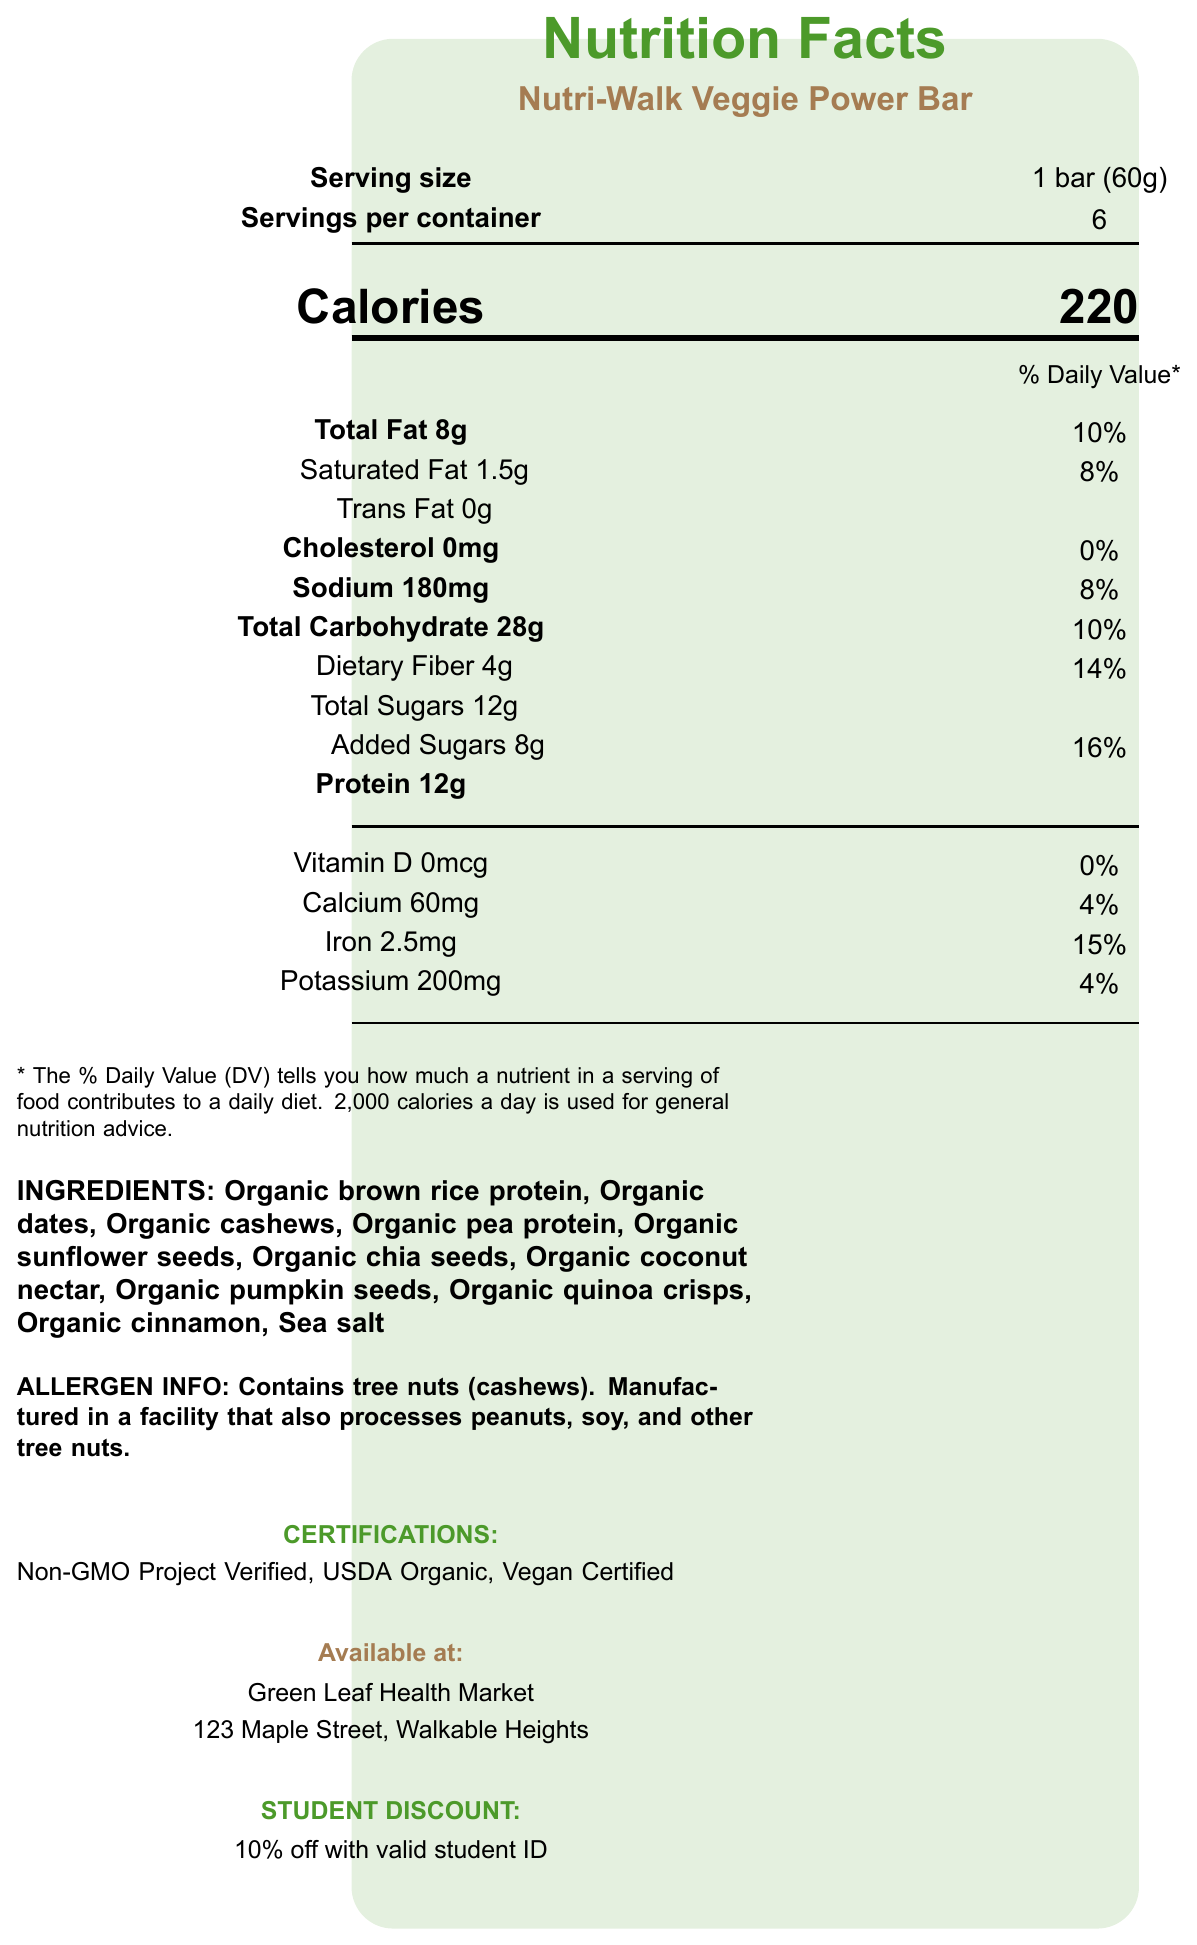what is the serving size? The serving size is listed in the "Serving information" section as "1 bar (60g)".
Answer: 1 bar (60g) how many calories are in one serving? The calories are clearly indicated in the "Calories" section of the document.
Answer: 220 what is the total fat content per serving? The "Total Fat" content is listed under the "Nutrients" section as 8g.
Answer: 8g how much fiber is in each serving? The "Dietary Fiber" content is specified in the "Nutrients" section as 4g.
Answer: 4g are there any added sugars in the protein bar? The document lists "Added Sugars" in the "Nutrients" section with an amount of 8g.
Answer: Yes what certifications does the Nutri-Walk Veggie Power Bar have? The certifications are listed in the "Certifications" section.
Answer: Non-GMO Project Verified, USDA Organic, Vegan Certified what is the amount of sodium per serving? The sodium content is listed under the "Nutrients" section as 180mg.
Answer: 180mg how many bars are in one container? The "Servings per container" is listed in the "Serving information" section as 6.
Answer: 6 which ingredient might cause allergies? The "Allergen Info" states that the bar contains tree nuts (cashews).
Answer: Cashews where can you buy this protein bar? The "Available at" section specifies that the bar can be purchased at Green Leaf Health Market.
Answer: Green Leaf Health Market how much iron does one serving have? The iron content is specified under "Nutrients" as 2.5mg.
Answer: 2.5mg what promotion is available for students? The "Student Discount" section provides information about a 10% discount with a valid student ID.
Answer: 10% off with valid student ID how much of the daily value of dietary fiber does one serving provide? The daily value percentage for dietary fiber is listed as 14% in the "Nutrients" section.
Answer: 14% how many grams of protein are in one bar? The protein content per serving is listed under "Nutrients" as 12g.
Answer: 12g what is the founder's name and purpose for starting the brand? The "Brand Story" section mentions that Sarah Chen founded the brand to provide sustainable, plant-based nutrition.
Answer: Sarah Chen, to provide sustainable, plant-based nutrition for active community members is the amount of calcium provided significant? The daily value percentage for calcium is listed as 4%, which is relatively low.
Answer: No how is the packaging of this product environmentally friendly? The "Sustainability Info" section states that the packaging is made from 100% post-consumer recycled materials.
Answer: Packaging made from 100% post-consumer recycled materials what is the major carbohydrate component per serving? A. Dietary Fiber B. Total Sugars C. Added Sugars While both dietary fiber and added sugars are components, "Total Sugars" is the major carbohydrate component with 12g.
Answer: B how much potassium is provided per serving? A. 100mg B. 150mg C. 200mg The potassium content is listed as 200mg.
Answer: C does the bar contain any cholesterol? The "Cholesterol" section specifies "0mg" which means it does not contain any cholesterol.
Answer: No what percent of the ingredients are locally sourced? The "Local Sourcing" section states that 60% of ingredients are sourced from farms within 100 miles.
Answer: 60% how much of the daily value of added sugars does one bar contribute? The daily value percentage for added sugars is listed as 16%.
Answer: 16% describe the overall content and focus of the document. The document gives a comprehensive overview of the Nutri-Walk Veggie Power Bar, emphasizing its nutritional values, ingredients, allergen warnings, certifications, and various benefits, including sustainability and local sourcing. It also mentions where to buy it and associated discounts.
Answer: The document provides detailed nutritional information, ingredient list, allergen info, certifications, sustainability practices, brand story, and discount offers for the Nutri-Walk Veggie Power Bar. It highlights the product's health benefits and eco-friendly aspects, supporting local sourcing and student discounts. how much protein is in a container? The document provides protein content per serving (12g), but not for the entire container.
Answer: Not enough information 